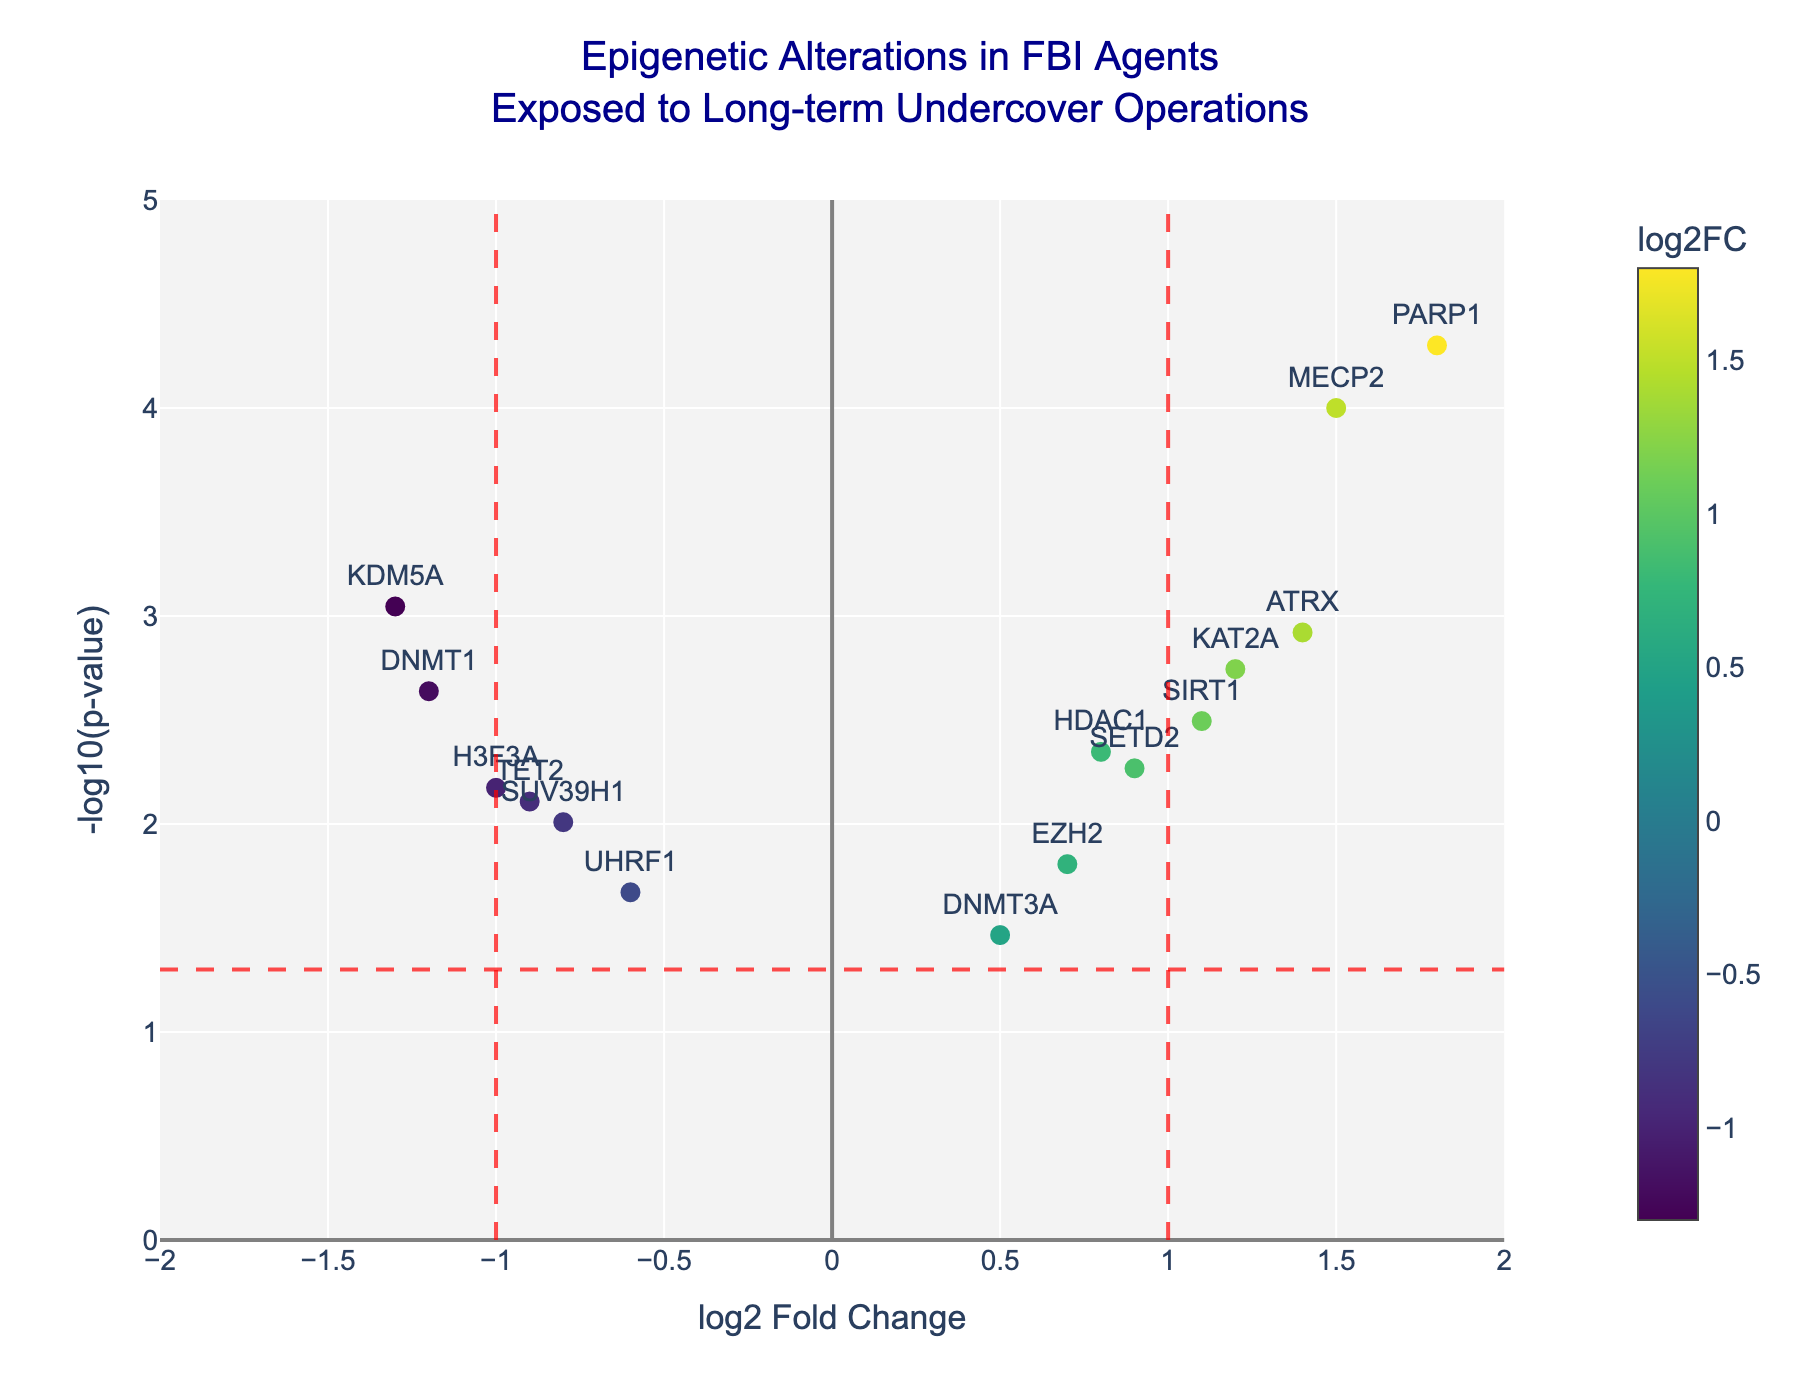What is the title of the plot? The title is generally found at the top of the plot and provides an overview of the context and focus of the figure. In this case, the title is: "Epigenetic Alterations in FBI Agents Exposed to Long-term Undercover Operations"
Answer: Epigenetic Alterations in FBI Agents Exposed to Long-term Undercover Operations What does the x-axis represent? The label of the x-axis typically describes what the x-axis values signify. Here, the x-axis represents "log2 Fold Change" indicating the ratio of gene expression levels of a gene between two conditions on a log base 2 scale.
Answer: log2 Fold Change What is the meaning of the red vertical lines on the plot? The red vertical lines are often used to indicate thresholds of biological significance. In this case, they represent log2 Fold Change values of -1 and 1, which are common cutoff points to deem changes in gene expression as meaningful.
Answer: log2 Fold Change thresholds of -1 and 1 Which gene has the highest p-value and what's its significance level? Identify the point with the lowest -log10(pValue) on the plot and refer to the hover text for its exact p-value. UHRF1 has the highest p-value (smallest -log10(pValue)). The significance level (p-value) of UHRF1 is 0.0213.
Answer: UHRF1, 0.0213 How many genes have a log2 Fold Change greater than 1? Count the number of points to the right of the log2 Fold Change value of 1. The genes with log2 Fold Change greater than 1 are MECP2, PARP1, KAT2A, SIRT1, and ATRX. That makes 5 genes.
Answer: 5 Which gene shows the most significant change in p-values? Look for the point with the highest -log10(pValue) on the plot, which signifies the smallest p-value. The gene PARP1 has the highest significance with a p-value of 0.00005.
Answer: PARP1 What is the log2 Fold Change for the gene with the smallest p-value? Identify the point corresponding to the smallest p-value and check the log2 Fold Change value from the hover text or the data. The gene PARP1 has the smallest p-value with a log2 Fold Change of 1.8.
Answer: 1.8 Are there more genes with positive or negative log2 Fold Change values? Count the number of points to the left and right of log2 Fold Change value 0. There are 7 genes with negative log2 Fold Change values and 8 with positive. Thus, more genes have positive values.
Answer: Positive What is the log2 Fold Change and p-value of KDM5A? Locate the gene "KDM5A" on the plot and refer to the hover text for exact values. The gene KDM5A has a log2 Fold Change of -1.3 and a p-value of 0.0009.
Answer: -1.3, 0.0009 Which genes fall under the highly significant category (p-value < 0.01) with absolute log2 Fold Change greater than 1? Identify genes meeting both criteria: p-value < 0.01 (log10 > 2) and absolute log2 Fold Change > 1. These genes are DNMT1 (-1.2, 0.0023), KDM5A (-1.3, 0.0009), PARP1 (1.8, 0.00005), and MECP2 (1.5, 0.0001).
Answer: DNMT1, KDM5A, PARP1, MECP2 